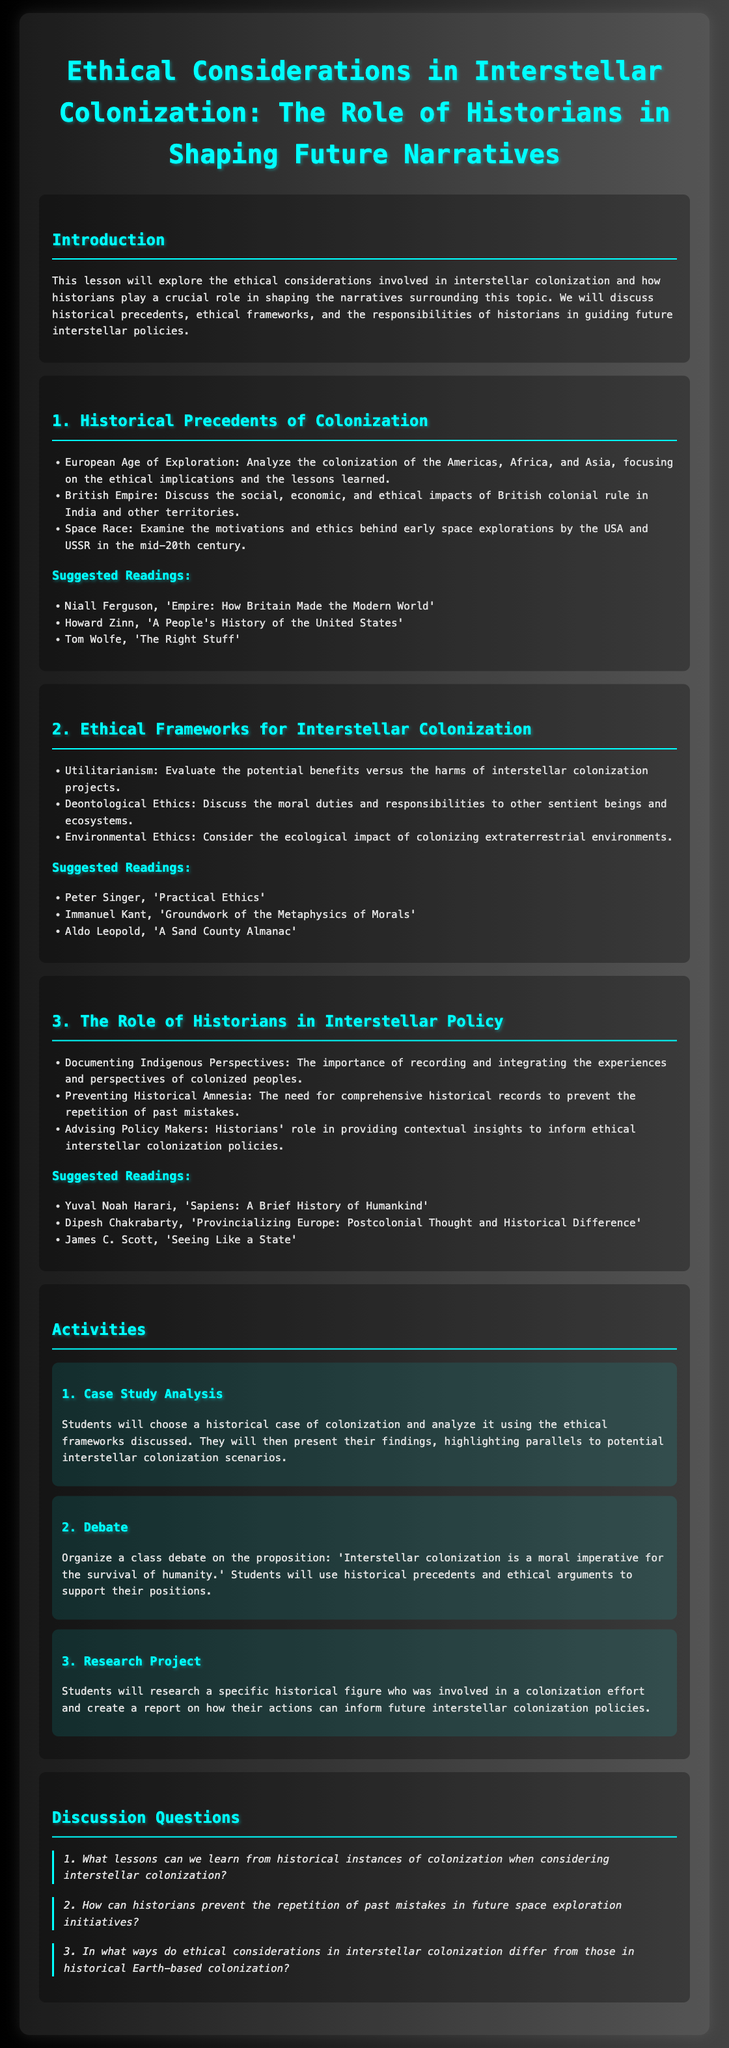What is the title of the lesson plan? The title reflects the main subject and theme of the lesson, which is about ethical considerations in interstellar colonization.
Answer: Ethical Considerations in Interstellar Colonization: The Role of Historians in Shaping Future Narratives What historical event is analyzed in the first section? The first section discusses the European Age of Exploration and its ethical implications as a major historical precedent for colonization.
Answer: European Age of Exploration Who is the author of 'A Sand County Almanac'? This question focuses on the suggested reading list in the second section, particularly an influential work relating to environmental ethics.
Answer: Aldo Leopold How many activities are listed in the activities section? The activities section enumerates the interactive activities designed for students to engage with the lesson content, totaling three.
Answer: 3 What is the proposition for the debate activity? The debate activity invites students to argue a specific statement related to the necessity of interstellar colonization for human survival.
Answer: Interstellar colonization is a moral imperative for the survival of humanity What ethical framework is focused on moral duties? The document categorizes different ethical approaches, with one specifically addressing obligations and moral considerations.
Answer: Deontological Ethics What is emphasized in documenting Indigenous perspectives? The role of historians includes the communication and preservation of the experiences of colonized populations during the colonization discussions.
Answer: Recording and integrating the experiences and perspectives of colonized peoples How does the lesson plan prevent historical amnesia? The lesson emphasizes the importance of maintaining comprehensive historical records to avoid repeating past mistakes in future scenarios.
Answer: Comprehensive historical records 